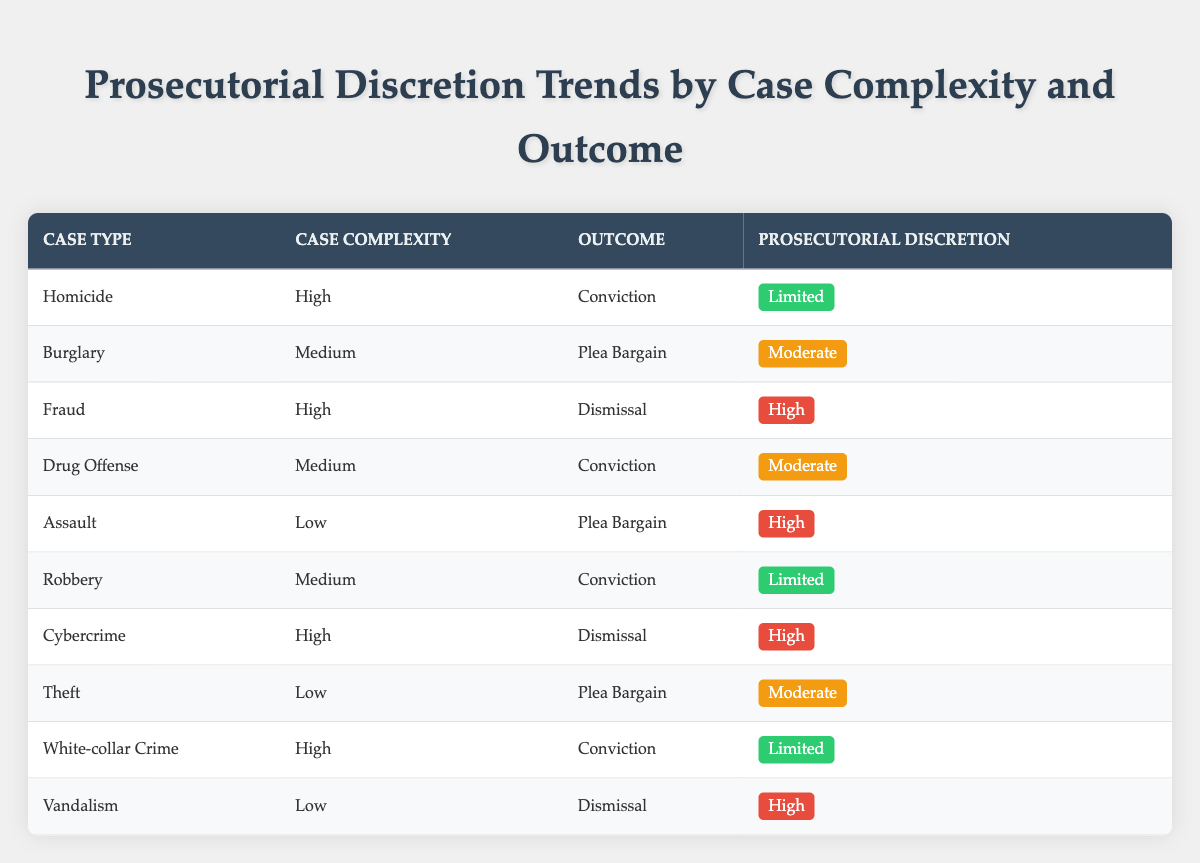What is the prosecutorial discretion level for the case type "Homicide"? The table shows that for the case type "Homicide," the prosecutorial discretion level is "Limited."
Answer: Limited Which case type with high complexity resulted in a dismissal? According to the table, "Fraud" and "Cybercrime" are the case types with high complexity that resulted in a dismissal.
Answer: Fraud, Cybercrime How many cases with medium complexity had a conviction outcome? By reviewing the table, we find two cases with medium complexity that resulted in a conviction: "Drug Offense" and "Robbery." Therefore, the total is 2.
Answer: 2 Is there any case type with low complexity that resulted in a conviction? The table does not list any case type with low complexity that had a conviction outcome. The only low complexity cases resulted in a plea bargain or dismissal.
Answer: No What proportion of high complexity cases resulted in a conviction? There are four high complexity cases: "Homicide," "Fraud," "Cybercrime," and "White-collar Crime." Out of these, only "Homicide," "Fraud," and "White-collar Crime" led to a conviction. This gives a proportion of 3 out of 4, which is 75%.
Answer: 75% In how many instances was the prosecutorial discretion level classified as "High"? The table shows that the prosecutorial discretion level is classified as "High" in three instances: for "Fraud," "Assault," and "Vandalism."
Answer: 3 Which case types resulted in a plea bargain outcome? The table lists "Burglary," "Assault," "Theft," and "Drug Offense" as the case types that resulted in a plea bargain outcome.
Answer: Burglary, Assault, Theft, Drug Offense What is the maximum prosecutorial discretion level for cases categorized as having high complexity? Reviewing the table, the maximum prosecutorial discretion level for high complexity cases is "High," which applies to the "Fraud" and "Cybercrime" cases.
Answer: High Are all low complexity cases resulting in a plea bargain? The table shows that "Assault," "Theft," and "Vandalism" are low complexity cases, where "Assault" and "Theft" resulted in a plea bargain, but "Vandalism" resulted in a dismissal. Hence, not all low complexity cases resulted in a plea bargain.
Answer: No 